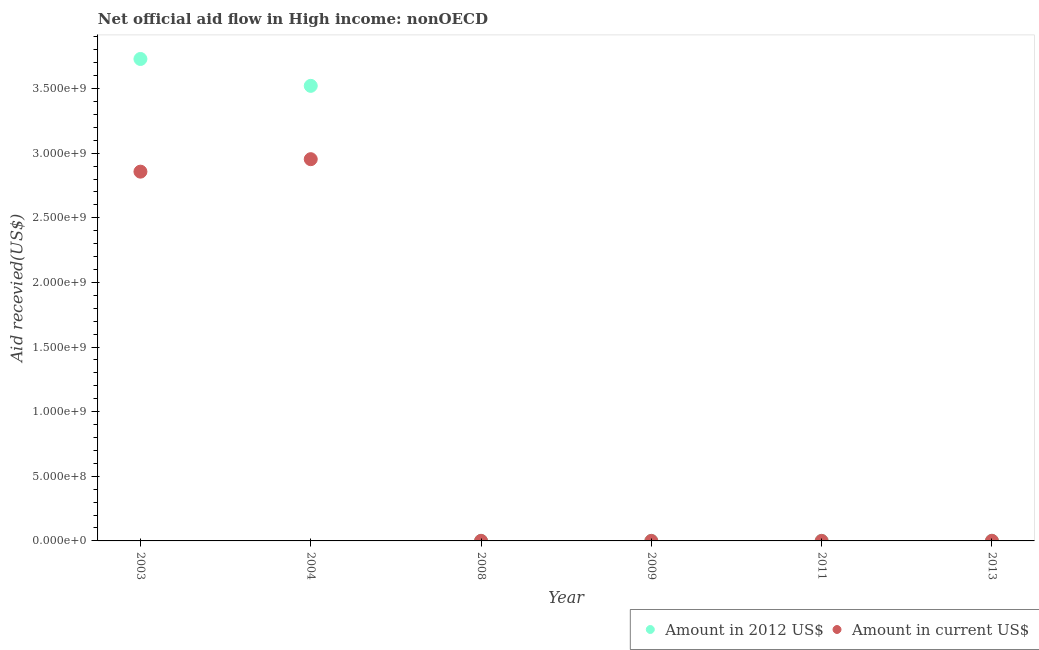How many different coloured dotlines are there?
Offer a terse response. 2. What is the amount of aid received(expressed in 2012 us$) in 2008?
Offer a very short reply. 7.20e+05. Across all years, what is the maximum amount of aid received(expressed in 2012 us$)?
Give a very brief answer. 3.73e+09. Across all years, what is the minimum amount of aid received(expressed in 2012 us$)?
Your answer should be very brief. 2.60e+05. What is the total amount of aid received(expressed in 2012 us$) in the graph?
Give a very brief answer. 7.25e+09. What is the difference between the amount of aid received(expressed in us$) in 2009 and that in 2013?
Give a very brief answer. -7.10e+05. What is the difference between the amount of aid received(expressed in us$) in 2004 and the amount of aid received(expressed in 2012 us$) in 2008?
Your answer should be very brief. 2.95e+09. What is the average amount of aid received(expressed in us$) per year?
Provide a short and direct response. 9.69e+08. In the year 2011, what is the difference between the amount of aid received(expressed in 2012 us$) and amount of aid received(expressed in us$)?
Give a very brief answer. -2.00e+04. In how many years, is the amount of aid received(expressed in us$) greater than 3300000000 US$?
Make the answer very short. 0. What is the ratio of the amount of aid received(expressed in us$) in 2003 to that in 2004?
Provide a short and direct response. 0.97. What is the difference between the highest and the second highest amount of aid received(expressed in 2012 us$)?
Your answer should be compact. 2.08e+08. What is the difference between the highest and the lowest amount of aid received(expressed in 2012 us$)?
Your answer should be compact. 3.73e+09. In how many years, is the amount of aid received(expressed in us$) greater than the average amount of aid received(expressed in us$) taken over all years?
Give a very brief answer. 2. Does the amount of aid received(expressed in 2012 us$) monotonically increase over the years?
Provide a succinct answer. No. Is the amount of aid received(expressed in us$) strictly less than the amount of aid received(expressed in 2012 us$) over the years?
Your response must be concise. No. How many years are there in the graph?
Keep it short and to the point. 6. Does the graph contain grids?
Your response must be concise. No. What is the title of the graph?
Ensure brevity in your answer.  Net official aid flow in High income: nonOECD. What is the label or title of the Y-axis?
Your response must be concise. Aid recevied(US$). What is the Aid recevied(US$) in Amount in 2012 US$ in 2003?
Provide a succinct answer. 3.73e+09. What is the Aid recevied(US$) of Amount in current US$ in 2003?
Offer a very short reply. 2.86e+09. What is the Aid recevied(US$) in Amount in 2012 US$ in 2004?
Your answer should be very brief. 3.52e+09. What is the Aid recevied(US$) of Amount in current US$ in 2004?
Ensure brevity in your answer.  2.95e+09. What is the Aid recevied(US$) in Amount in 2012 US$ in 2008?
Give a very brief answer. 7.20e+05. What is the Aid recevied(US$) in Amount in current US$ in 2008?
Give a very brief answer. 7.10e+05. What is the Aid recevied(US$) of Amount in 2012 US$ in 2009?
Your response must be concise. 3.00e+05. What is the Aid recevied(US$) in Amount in 2012 US$ in 2011?
Provide a succinct answer. 2.60e+05. What is the Aid recevied(US$) of Amount in current US$ in 2011?
Ensure brevity in your answer.  2.80e+05. What is the Aid recevied(US$) of Amount in 2012 US$ in 2013?
Provide a succinct answer. 1.00e+06. What is the Aid recevied(US$) of Amount in current US$ in 2013?
Your response must be concise. 1.00e+06. Across all years, what is the maximum Aid recevied(US$) in Amount in 2012 US$?
Offer a very short reply. 3.73e+09. Across all years, what is the maximum Aid recevied(US$) in Amount in current US$?
Your answer should be very brief. 2.95e+09. Across all years, what is the minimum Aid recevied(US$) in Amount in 2012 US$?
Offer a very short reply. 2.60e+05. What is the total Aid recevied(US$) in Amount in 2012 US$ in the graph?
Keep it short and to the point. 7.25e+09. What is the total Aid recevied(US$) of Amount in current US$ in the graph?
Give a very brief answer. 5.81e+09. What is the difference between the Aid recevied(US$) of Amount in 2012 US$ in 2003 and that in 2004?
Provide a succinct answer. 2.08e+08. What is the difference between the Aid recevied(US$) of Amount in current US$ in 2003 and that in 2004?
Provide a succinct answer. -9.65e+07. What is the difference between the Aid recevied(US$) in Amount in 2012 US$ in 2003 and that in 2008?
Keep it short and to the point. 3.73e+09. What is the difference between the Aid recevied(US$) of Amount in current US$ in 2003 and that in 2008?
Make the answer very short. 2.86e+09. What is the difference between the Aid recevied(US$) of Amount in 2012 US$ in 2003 and that in 2009?
Ensure brevity in your answer.  3.73e+09. What is the difference between the Aid recevied(US$) in Amount in current US$ in 2003 and that in 2009?
Provide a succinct answer. 2.86e+09. What is the difference between the Aid recevied(US$) in Amount in 2012 US$ in 2003 and that in 2011?
Offer a very short reply. 3.73e+09. What is the difference between the Aid recevied(US$) in Amount in current US$ in 2003 and that in 2011?
Offer a very short reply. 2.86e+09. What is the difference between the Aid recevied(US$) in Amount in 2012 US$ in 2003 and that in 2013?
Ensure brevity in your answer.  3.73e+09. What is the difference between the Aid recevied(US$) in Amount in current US$ in 2003 and that in 2013?
Offer a terse response. 2.86e+09. What is the difference between the Aid recevied(US$) of Amount in 2012 US$ in 2004 and that in 2008?
Offer a terse response. 3.52e+09. What is the difference between the Aid recevied(US$) in Amount in current US$ in 2004 and that in 2008?
Offer a very short reply. 2.95e+09. What is the difference between the Aid recevied(US$) in Amount in 2012 US$ in 2004 and that in 2009?
Your response must be concise. 3.52e+09. What is the difference between the Aid recevied(US$) of Amount in current US$ in 2004 and that in 2009?
Give a very brief answer. 2.95e+09. What is the difference between the Aid recevied(US$) of Amount in 2012 US$ in 2004 and that in 2011?
Provide a short and direct response. 3.52e+09. What is the difference between the Aid recevied(US$) of Amount in current US$ in 2004 and that in 2011?
Provide a succinct answer. 2.95e+09. What is the difference between the Aid recevied(US$) of Amount in 2012 US$ in 2004 and that in 2013?
Keep it short and to the point. 3.52e+09. What is the difference between the Aid recevied(US$) of Amount in current US$ in 2004 and that in 2013?
Give a very brief answer. 2.95e+09. What is the difference between the Aid recevied(US$) of Amount in current US$ in 2008 and that in 2009?
Your answer should be compact. 4.20e+05. What is the difference between the Aid recevied(US$) of Amount in current US$ in 2008 and that in 2011?
Your answer should be very brief. 4.30e+05. What is the difference between the Aid recevied(US$) in Amount in 2012 US$ in 2008 and that in 2013?
Offer a terse response. -2.80e+05. What is the difference between the Aid recevied(US$) in Amount in 2012 US$ in 2009 and that in 2011?
Make the answer very short. 4.00e+04. What is the difference between the Aid recevied(US$) of Amount in current US$ in 2009 and that in 2011?
Your response must be concise. 10000. What is the difference between the Aid recevied(US$) of Amount in 2012 US$ in 2009 and that in 2013?
Ensure brevity in your answer.  -7.00e+05. What is the difference between the Aid recevied(US$) in Amount in current US$ in 2009 and that in 2013?
Make the answer very short. -7.10e+05. What is the difference between the Aid recevied(US$) of Amount in 2012 US$ in 2011 and that in 2013?
Provide a short and direct response. -7.40e+05. What is the difference between the Aid recevied(US$) in Amount in current US$ in 2011 and that in 2013?
Ensure brevity in your answer.  -7.20e+05. What is the difference between the Aid recevied(US$) of Amount in 2012 US$ in 2003 and the Aid recevied(US$) of Amount in current US$ in 2004?
Ensure brevity in your answer.  7.75e+08. What is the difference between the Aid recevied(US$) in Amount in 2012 US$ in 2003 and the Aid recevied(US$) in Amount in current US$ in 2008?
Make the answer very short. 3.73e+09. What is the difference between the Aid recevied(US$) in Amount in 2012 US$ in 2003 and the Aid recevied(US$) in Amount in current US$ in 2009?
Make the answer very short. 3.73e+09. What is the difference between the Aid recevied(US$) in Amount in 2012 US$ in 2003 and the Aid recevied(US$) in Amount in current US$ in 2011?
Your answer should be compact. 3.73e+09. What is the difference between the Aid recevied(US$) of Amount in 2012 US$ in 2003 and the Aid recevied(US$) of Amount in current US$ in 2013?
Give a very brief answer. 3.73e+09. What is the difference between the Aid recevied(US$) in Amount in 2012 US$ in 2004 and the Aid recevied(US$) in Amount in current US$ in 2008?
Keep it short and to the point. 3.52e+09. What is the difference between the Aid recevied(US$) in Amount in 2012 US$ in 2004 and the Aid recevied(US$) in Amount in current US$ in 2009?
Provide a short and direct response. 3.52e+09. What is the difference between the Aid recevied(US$) of Amount in 2012 US$ in 2004 and the Aid recevied(US$) of Amount in current US$ in 2011?
Offer a very short reply. 3.52e+09. What is the difference between the Aid recevied(US$) in Amount in 2012 US$ in 2004 and the Aid recevied(US$) in Amount in current US$ in 2013?
Offer a very short reply. 3.52e+09. What is the difference between the Aid recevied(US$) in Amount in 2012 US$ in 2008 and the Aid recevied(US$) in Amount in current US$ in 2009?
Keep it short and to the point. 4.30e+05. What is the difference between the Aid recevied(US$) of Amount in 2012 US$ in 2008 and the Aid recevied(US$) of Amount in current US$ in 2011?
Your answer should be very brief. 4.40e+05. What is the difference between the Aid recevied(US$) of Amount in 2012 US$ in 2008 and the Aid recevied(US$) of Amount in current US$ in 2013?
Provide a succinct answer. -2.80e+05. What is the difference between the Aid recevied(US$) in Amount in 2012 US$ in 2009 and the Aid recevied(US$) in Amount in current US$ in 2013?
Your answer should be compact. -7.00e+05. What is the difference between the Aid recevied(US$) in Amount in 2012 US$ in 2011 and the Aid recevied(US$) in Amount in current US$ in 2013?
Offer a very short reply. -7.40e+05. What is the average Aid recevied(US$) of Amount in 2012 US$ per year?
Give a very brief answer. 1.21e+09. What is the average Aid recevied(US$) in Amount in current US$ per year?
Make the answer very short. 9.69e+08. In the year 2003, what is the difference between the Aid recevied(US$) of Amount in 2012 US$ and Aid recevied(US$) of Amount in current US$?
Provide a succinct answer. 8.72e+08. In the year 2004, what is the difference between the Aid recevied(US$) in Amount in 2012 US$ and Aid recevied(US$) in Amount in current US$?
Keep it short and to the point. 5.67e+08. In the year 2008, what is the difference between the Aid recevied(US$) in Amount in 2012 US$ and Aid recevied(US$) in Amount in current US$?
Make the answer very short. 10000. In the year 2009, what is the difference between the Aid recevied(US$) in Amount in 2012 US$ and Aid recevied(US$) in Amount in current US$?
Provide a succinct answer. 10000. What is the ratio of the Aid recevied(US$) of Amount in 2012 US$ in 2003 to that in 2004?
Ensure brevity in your answer.  1.06. What is the ratio of the Aid recevied(US$) in Amount in current US$ in 2003 to that in 2004?
Ensure brevity in your answer.  0.97. What is the ratio of the Aid recevied(US$) of Amount in 2012 US$ in 2003 to that in 2008?
Keep it short and to the point. 5179.39. What is the ratio of the Aid recevied(US$) of Amount in current US$ in 2003 to that in 2008?
Keep it short and to the point. 4024.31. What is the ratio of the Aid recevied(US$) in Amount in 2012 US$ in 2003 to that in 2009?
Your response must be concise. 1.24e+04. What is the ratio of the Aid recevied(US$) in Amount in current US$ in 2003 to that in 2009?
Make the answer very short. 9852.62. What is the ratio of the Aid recevied(US$) in Amount in 2012 US$ in 2003 to that in 2011?
Offer a terse response. 1.43e+04. What is the ratio of the Aid recevied(US$) of Amount in current US$ in 2003 to that in 2011?
Offer a terse response. 1.02e+04. What is the ratio of the Aid recevied(US$) of Amount in 2012 US$ in 2003 to that in 2013?
Your answer should be compact. 3729.16. What is the ratio of the Aid recevied(US$) of Amount in current US$ in 2003 to that in 2013?
Give a very brief answer. 2857.26. What is the ratio of the Aid recevied(US$) of Amount in 2012 US$ in 2004 to that in 2008?
Your response must be concise. 4890.5. What is the ratio of the Aid recevied(US$) in Amount in current US$ in 2004 to that in 2008?
Keep it short and to the point. 4160.17. What is the ratio of the Aid recevied(US$) of Amount in 2012 US$ in 2004 to that in 2009?
Offer a very short reply. 1.17e+04. What is the ratio of the Aid recevied(US$) of Amount in current US$ in 2004 to that in 2009?
Provide a short and direct response. 1.02e+04. What is the ratio of the Aid recevied(US$) of Amount in 2012 US$ in 2004 to that in 2011?
Your answer should be very brief. 1.35e+04. What is the ratio of the Aid recevied(US$) of Amount in current US$ in 2004 to that in 2011?
Provide a short and direct response. 1.05e+04. What is the ratio of the Aid recevied(US$) of Amount in 2012 US$ in 2004 to that in 2013?
Your answer should be very brief. 3521.16. What is the ratio of the Aid recevied(US$) of Amount in current US$ in 2004 to that in 2013?
Offer a terse response. 2953.72. What is the ratio of the Aid recevied(US$) in Amount in current US$ in 2008 to that in 2009?
Provide a succinct answer. 2.45. What is the ratio of the Aid recevied(US$) of Amount in 2012 US$ in 2008 to that in 2011?
Your answer should be compact. 2.77. What is the ratio of the Aid recevied(US$) in Amount in current US$ in 2008 to that in 2011?
Provide a short and direct response. 2.54. What is the ratio of the Aid recevied(US$) of Amount in 2012 US$ in 2008 to that in 2013?
Give a very brief answer. 0.72. What is the ratio of the Aid recevied(US$) of Amount in current US$ in 2008 to that in 2013?
Your answer should be compact. 0.71. What is the ratio of the Aid recevied(US$) of Amount in 2012 US$ in 2009 to that in 2011?
Make the answer very short. 1.15. What is the ratio of the Aid recevied(US$) in Amount in current US$ in 2009 to that in 2011?
Give a very brief answer. 1.04. What is the ratio of the Aid recevied(US$) in Amount in 2012 US$ in 2009 to that in 2013?
Make the answer very short. 0.3. What is the ratio of the Aid recevied(US$) of Amount in current US$ in 2009 to that in 2013?
Offer a very short reply. 0.29. What is the ratio of the Aid recevied(US$) in Amount in 2012 US$ in 2011 to that in 2013?
Your response must be concise. 0.26. What is the ratio of the Aid recevied(US$) of Amount in current US$ in 2011 to that in 2013?
Your response must be concise. 0.28. What is the difference between the highest and the second highest Aid recevied(US$) of Amount in 2012 US$?
Provide a short and direct response. 2.08e+08. What is the difference between the highest and the second highest Aid recevied(US$) in Amount in current US$?
Keep it short and to the point. 9.65e+07. What is the difference between the highest and the lowest Aid recevied(US$) in Amount in 2012 US$?
Give a very brief answer. 3.73e+09. What is the difference between the highest and the lowest Aid recevied(US$) of Amount in current US$?
Offer a terse response. 2.95e+09. 